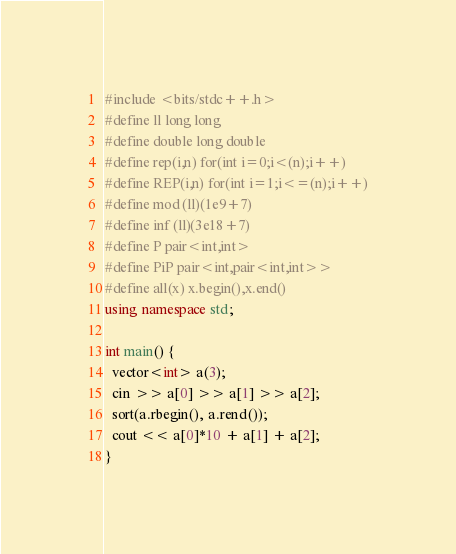Convert code to text. <code><loc_0><loc_0><loc_500><loc_500><_C++_>#include <bits/stdc++.h>
#define ll long long
#define double long double
#define rep(i,n) for(int i=0;i<(n);i++)
#define REP(i,n) for(int i=1;i<=(n);i++)
#define mod (ll)(1e9+7)
#define inf (ll)(3e18+7)
#define P pair<int,int>
#define PiP pair<int,pair<int,int>>
#define all(x) x.begin(),x.end()
using namespace std;

int main() {
  vector<int> a(3);
  cin >> a[0] >> a[1] >> a[2];
  sort(a.rbegin(), a.rend());
  cout << a[0]*10 + a[1] + a[2];
}</code> 